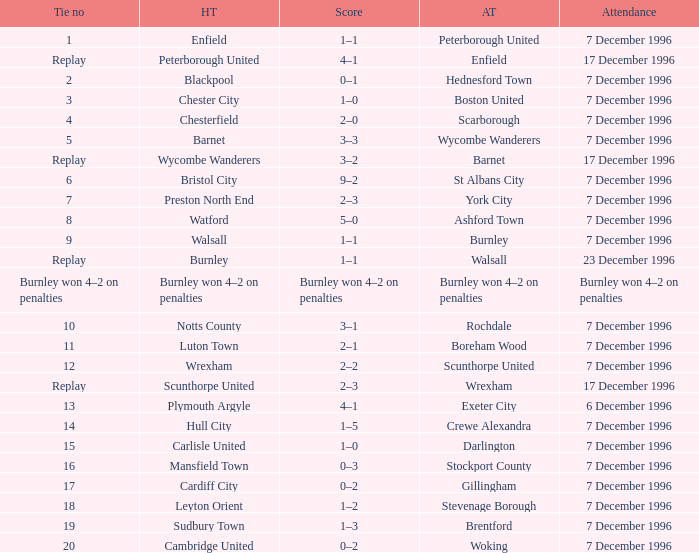Who were the away team in tie number 20? Woking. 